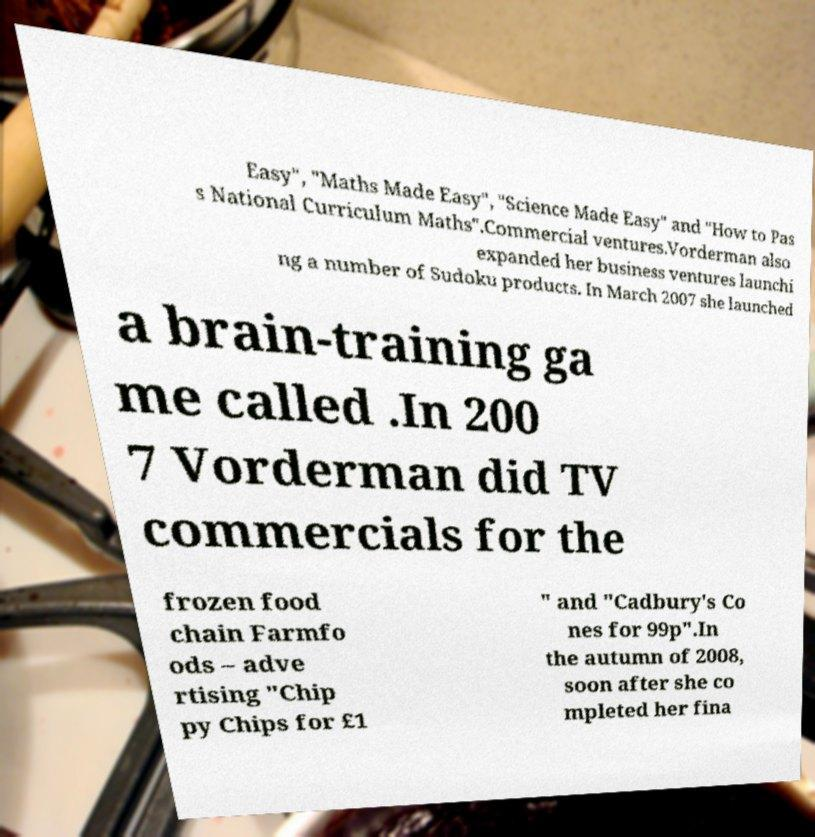Please read and relay the text visible in this image. What does it say? Easy", "Maths Made Easy", "Science Made Easy" and "How to Pas s National Curriculum Maths".Commercial ventures.Vorderman also expanded her business ventures launchi ng a number of Sudoku products. In March 2007 she launched a brain-training ga me called .In 200 7 Vorderman did TV commercials for the frozen food chain Farmfo ods – adve rtising "Chip py Chips for £1 " and "Cadbury's Co nes for 99p".In the autumn of 2008, soon after she co mpleted her fina 